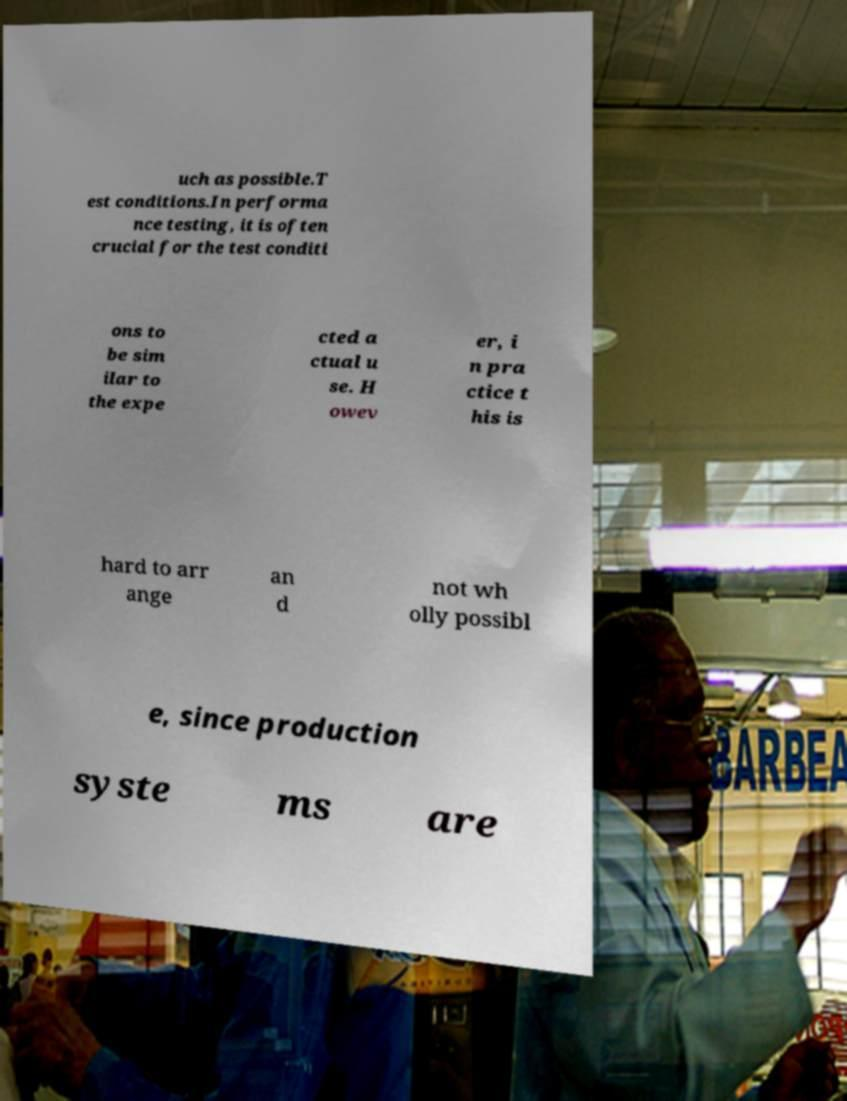Please read and relay the text visible in this image. What does it say? uch as possible.T est conditions.In performa nce testing, it is often crucial for the test conditi ons to be sim ilar to the expe cted a ctual u se. H owev er, i n pra ctice t his is hard to arr ange an d not wh olly possibl e, since production syste ms are 